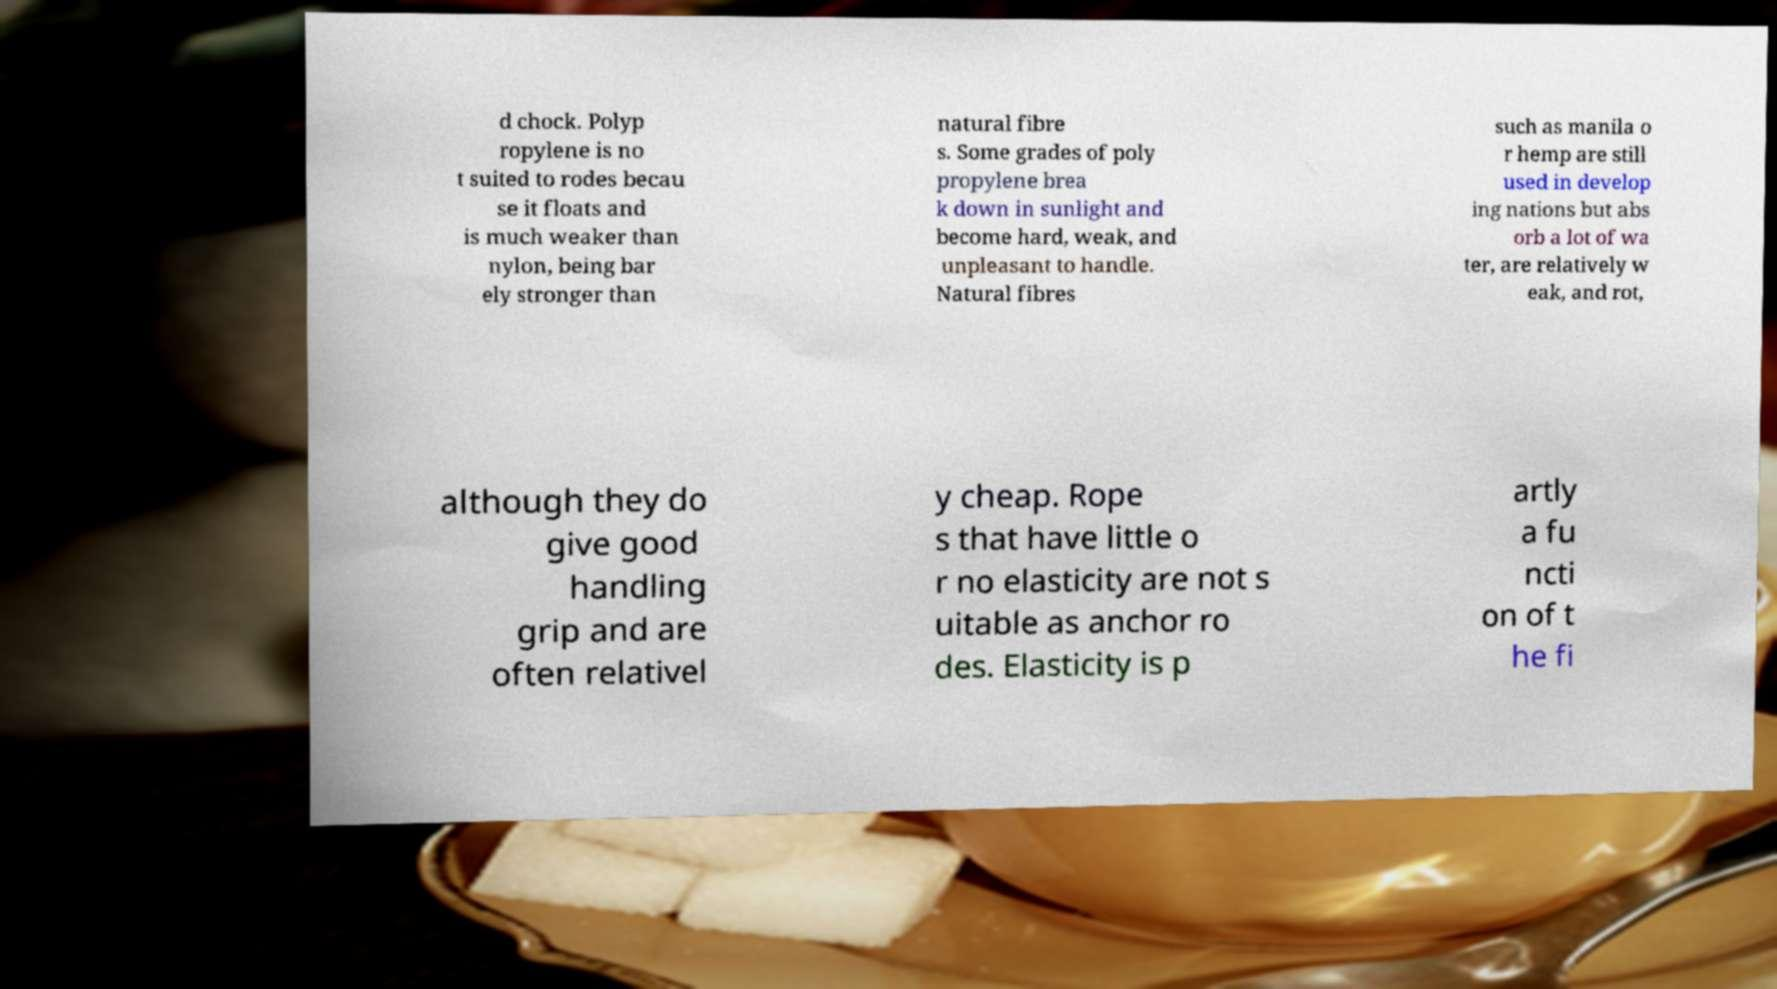Please identify and transcribe the text found in this image. d chock. Polyp ropylene is no t suited to rodes becau se it floats and is much weaker than nylon, being bar ely stronger than natural fibre s. Some grades of poly propylene brea k down in sunlight and become hard, weak, and unpleasant to handle. Natural fibres such as manila o r hemp are still used in develop ing nations but abs orb a lot of wa ter, are relatively w eak, and rot, although they do give good handling grip and are often relativel y cheap. Rope s that have little o r no elasticity are not s uitable as anchor ro des. Elasticity is p artly a fu ncti on of t he fi 